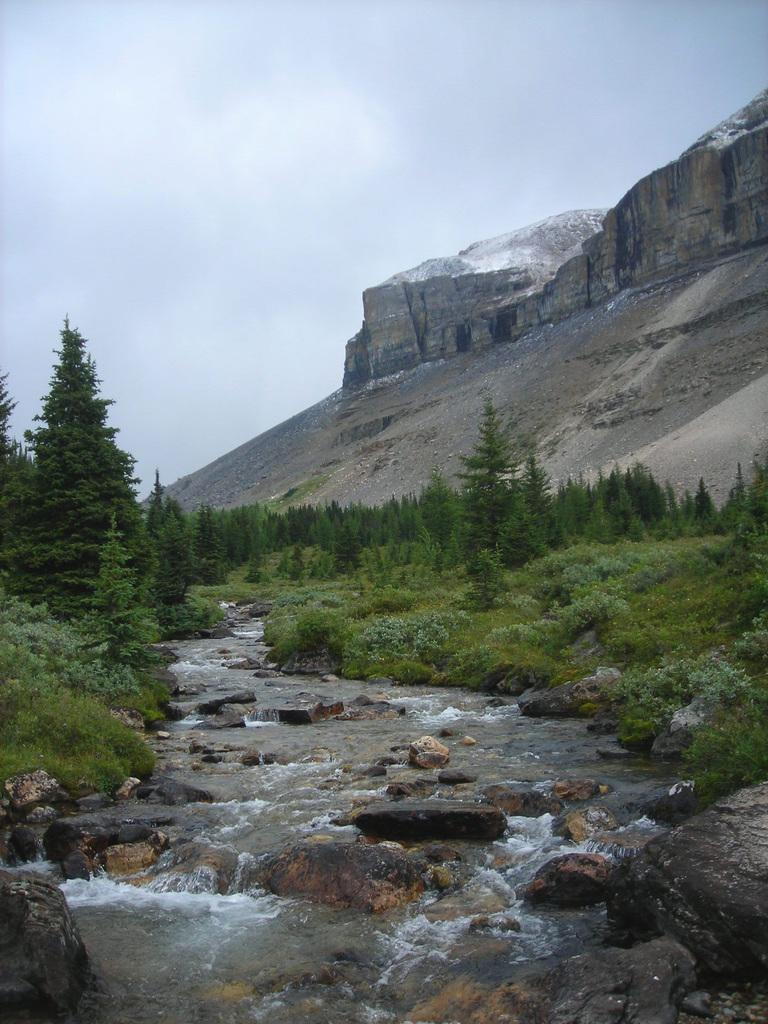What type of natural elements can be seen in the image? There are trees and a water flow visible in the image. What other objects can be found in the image? There are rocks in the image. What can be seen in the background of the image? There is a mountain and the sky visible in the background of the image. Can you tell me how many kittens are playing with snakes in the image? There are no kittens or snakes present in the image. What type of music is being played by the band in the image? There is no band present in the image. 